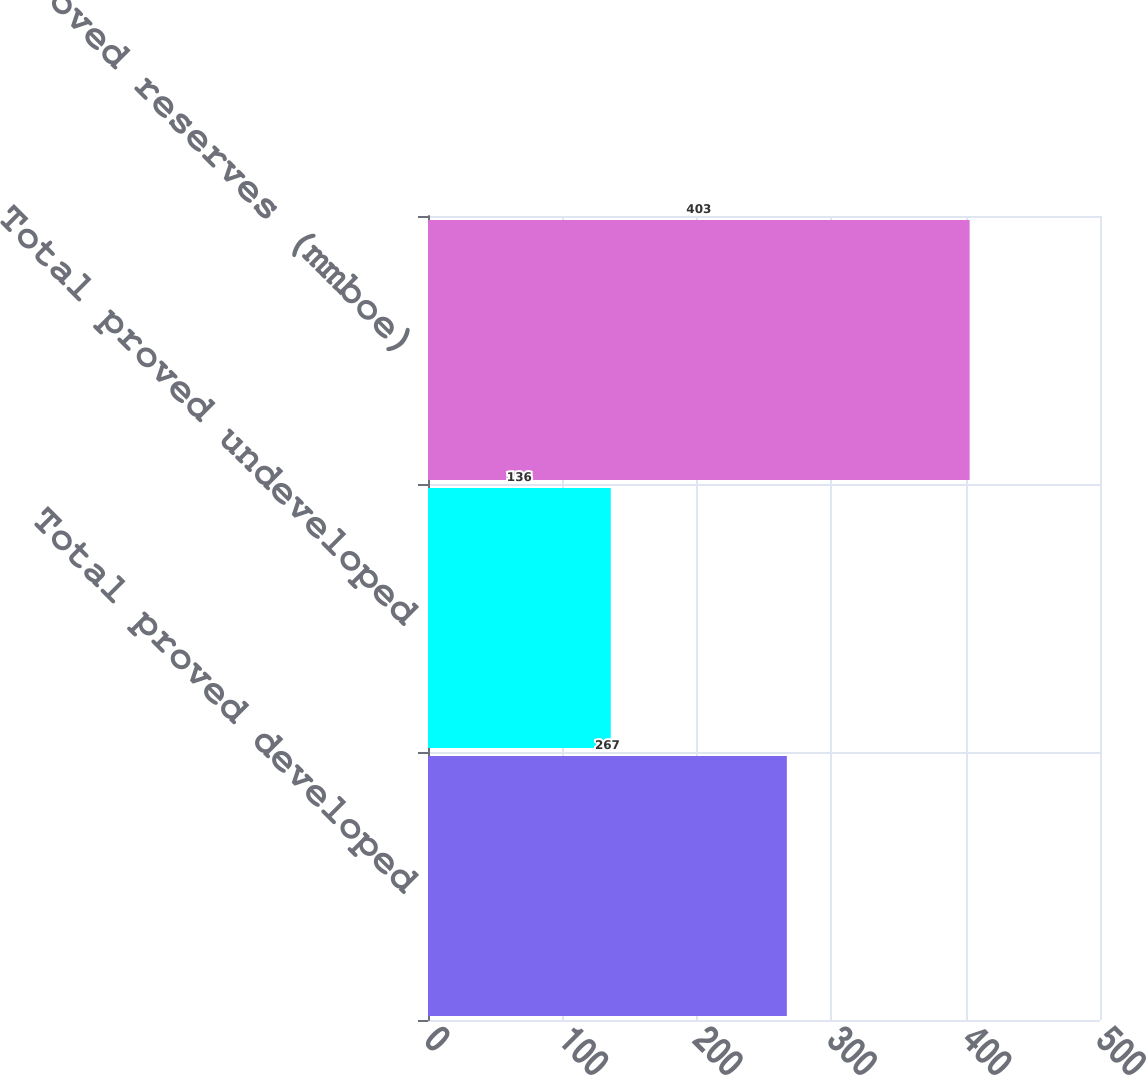<chart> <loc_0><loc_0><loc_500><loc_500><bar_chart><fcel>Total proved developed<fcel>Total proved undeveloped<fcel>Total proved reserves (mmboe)<nl><fcel>267<fcel>136<fcel>403<nl></chart> 